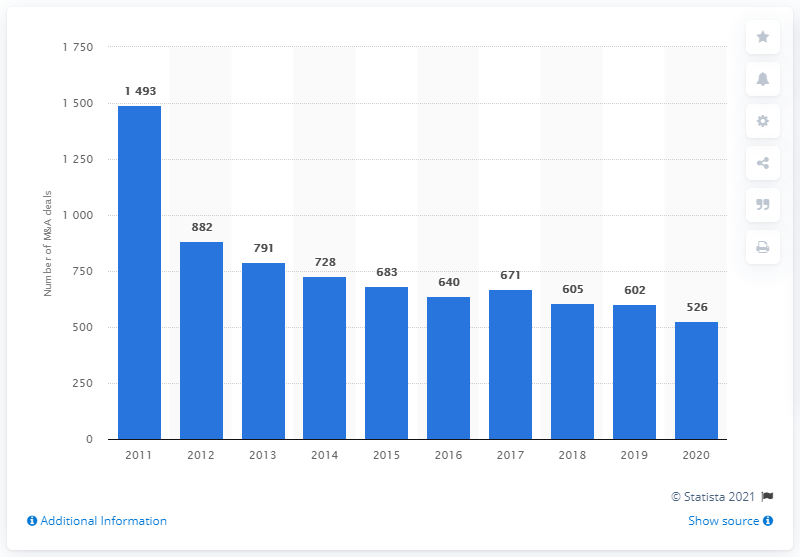Highlight a few significant elements in this photo. The total volume of M&A deals in Russia in 2020 was 526. In 2016, a total of 640 M&A transactions were completed. 